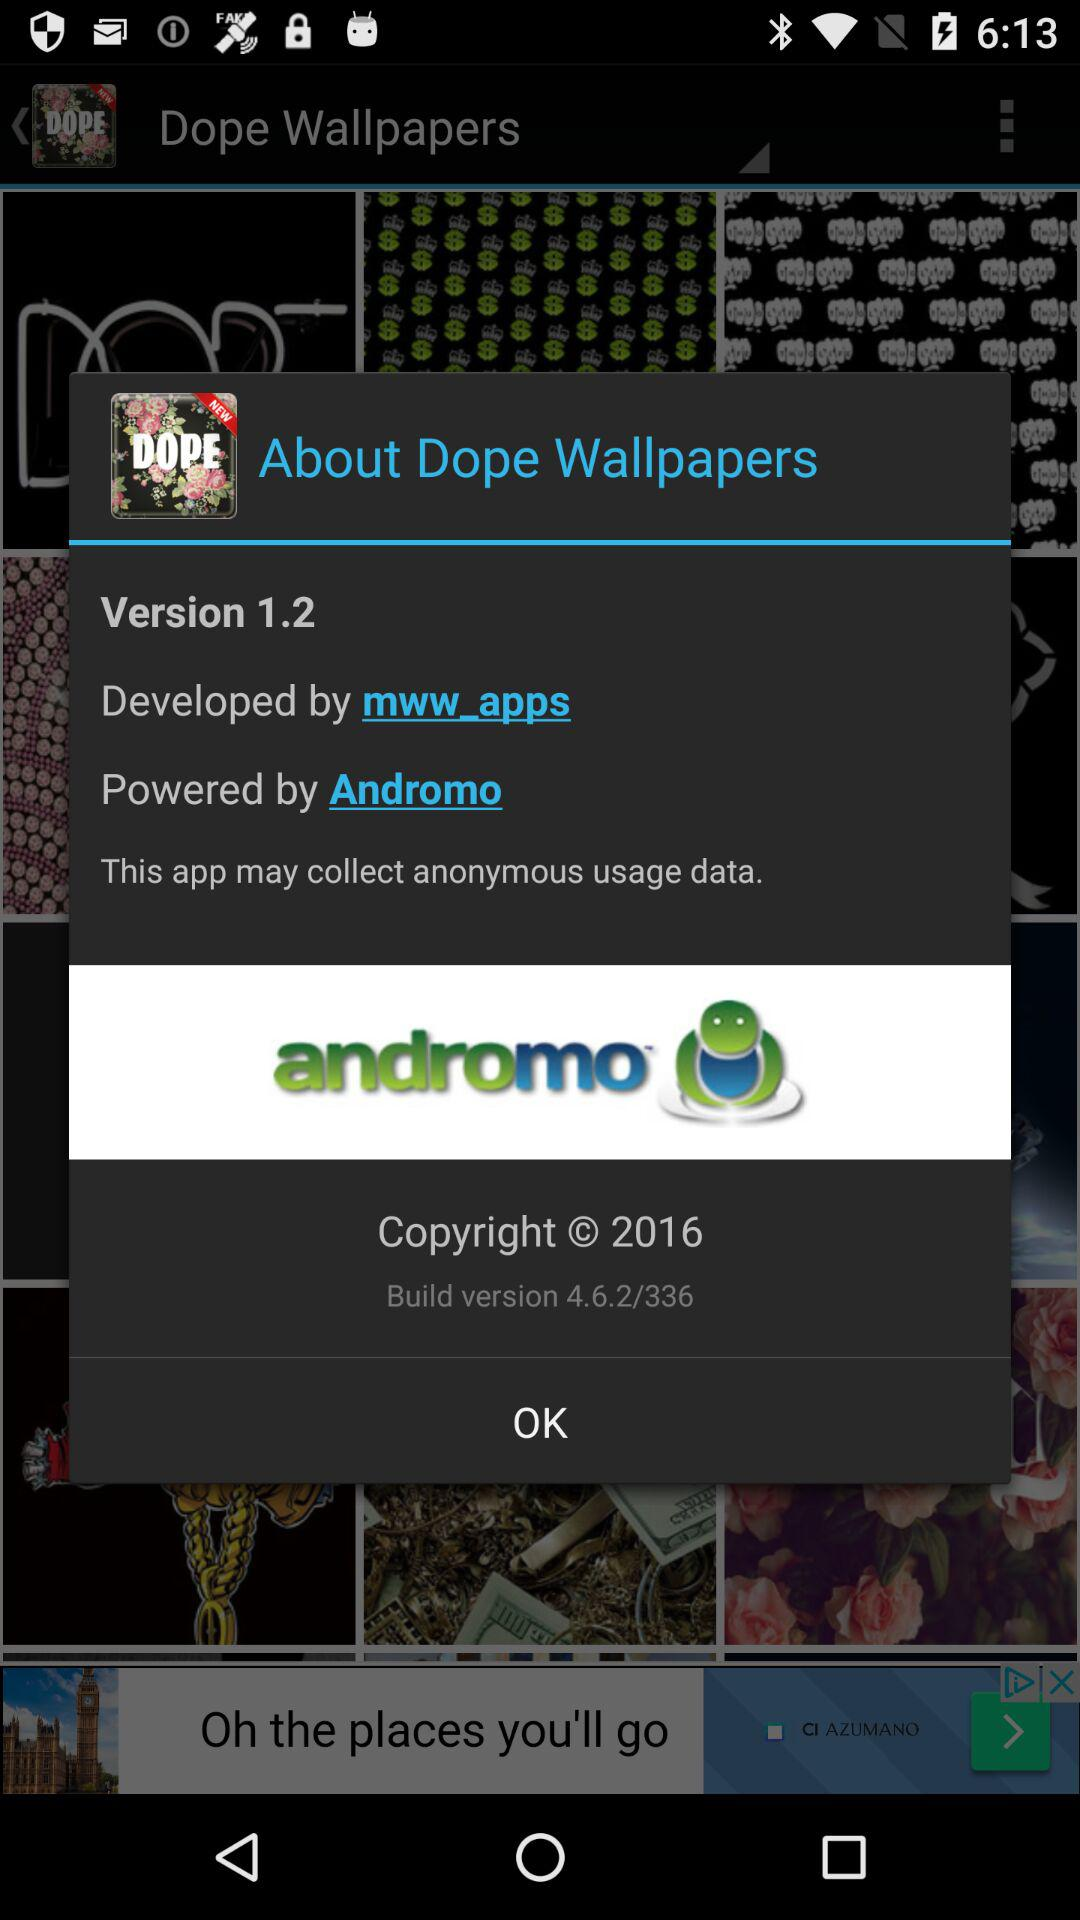Who is the developer of "Dope Wallpapers"? The developer is "mww_apps". 